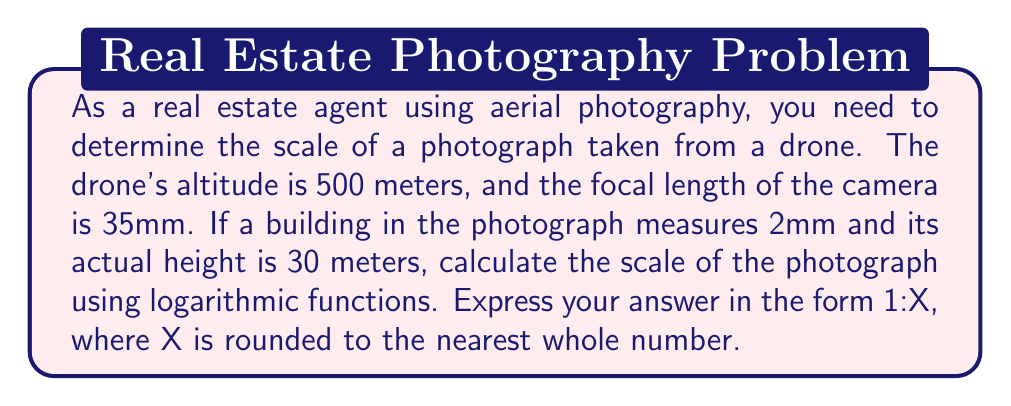Solve this math problem. Let's approach this step-by-step using logarithmic functions:

1) The scale of an aerial photograph is given by the formula:

   $$\text{Scale} = \frac{\text{focal length}}{\text{flying height}}$$

2) However, we need to find the ground distance represented by the 2mm measurement in the photo. Let's call this unknown distance $d$.

3) We can set up a proportion:
   $$\frac{2\text{ mm}}{30\text{ m}} = \frac{35\text{ mm}}{d}$$

4) Cross multiply:
   $$2d = 35 \cdot 30$$

5) Solve for $d$:
   $$d = \frac{35 \cdot 30}{2} = 525\text{ m}$$

6) Now we can calculate the scale:
   $$\text{Scale} = \frac{35\text{ mm}}{500\text{ m}} = \frac{35}{500000}$$

7) To express this as 1:X, we need to solve:
   $$\frac{1}{X} = \frac{35}{500000}$$

8) Cross multiply:
   $$500000 = 35X$$

9) Solve for X:
   $$X = \frac{500000}{35}$$

10) We can use logarithms to calculate this:
    $$\log X = \log 500000 - \log 35$$
    $$\log X = 5.69897 - 1.54407 = 4.15490$$

11) Therefore:
    $$X = 10^{4.15490} = 14285.7$$

12) Rounding to the nearest whole number:
    $$X \approx 14286$$
Answer: The scale of the aerial photograph is approximately 1:14286 